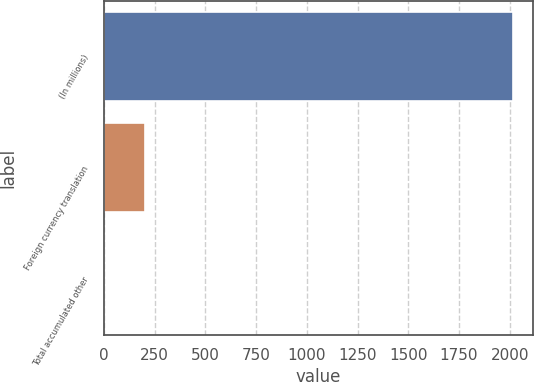Convert chart. <chart><loc_0><loc_0><loc_500><loc_500><bar_chart><fcel>(In millions)<fcel>Foreign currency translation<fcel>Total accumulated other<nl><fcel>2014<fcel>203.2<fcel>2<nl></chart> 